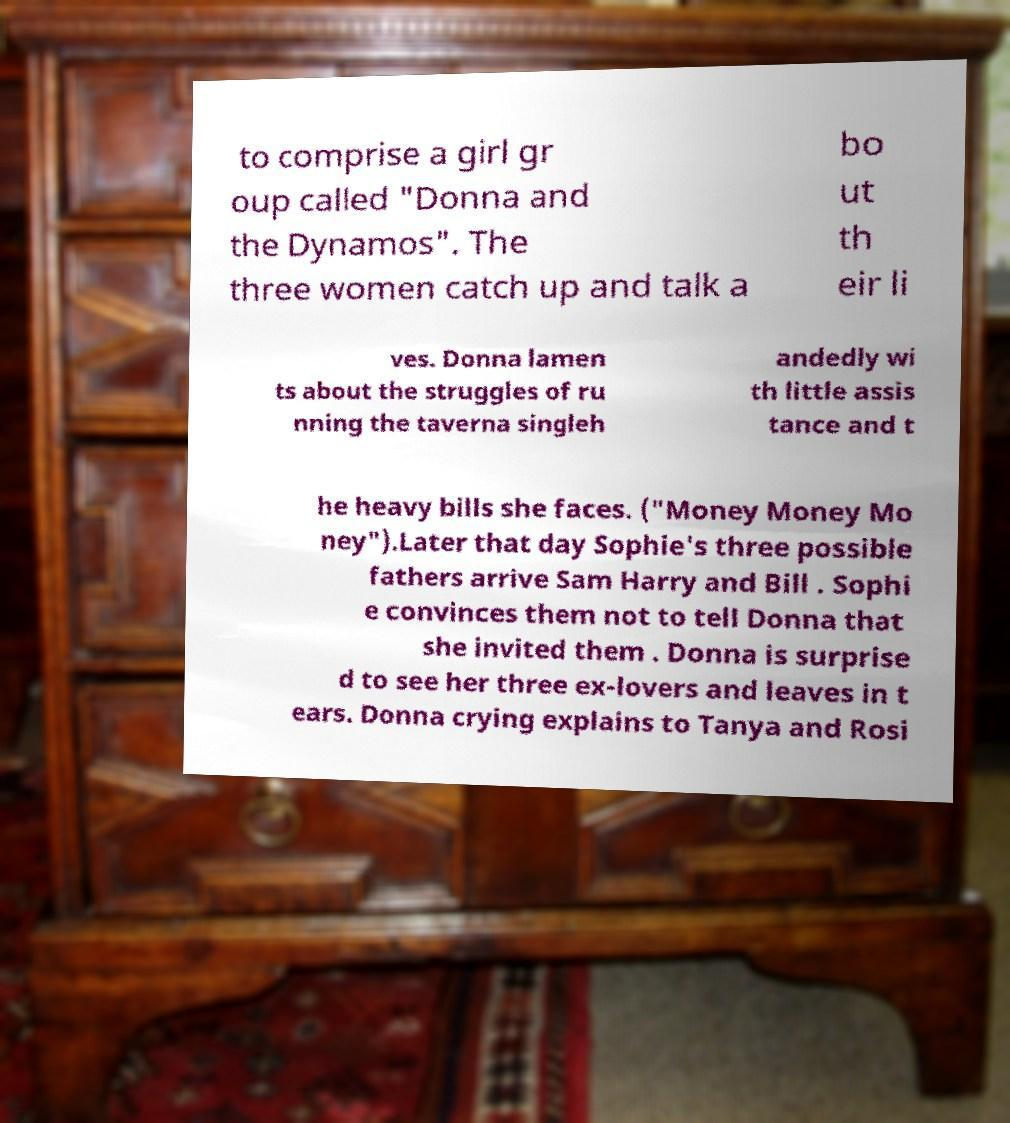Could you assist in decoding the text presented in this image and type it out clearly? to comprise a girl gr oup called "Donna and the Dynamos". The three women catch up and talk a bo ut th eir li ves. Donna lamen ts about the struggles of ru nning the taverna singleh andedly wi th little assis tance and t he heavy bills she faces. ("Money Money Mo ney").Later that day Sophie's three possible fathers arrive Sam Harry and Bill . Sophi e convinces them not to tell Donna that she invited them . Donna is surprise d to see her three ex-lovers and leaves in t ears. Donna crying explains to Tanya and Rosi 